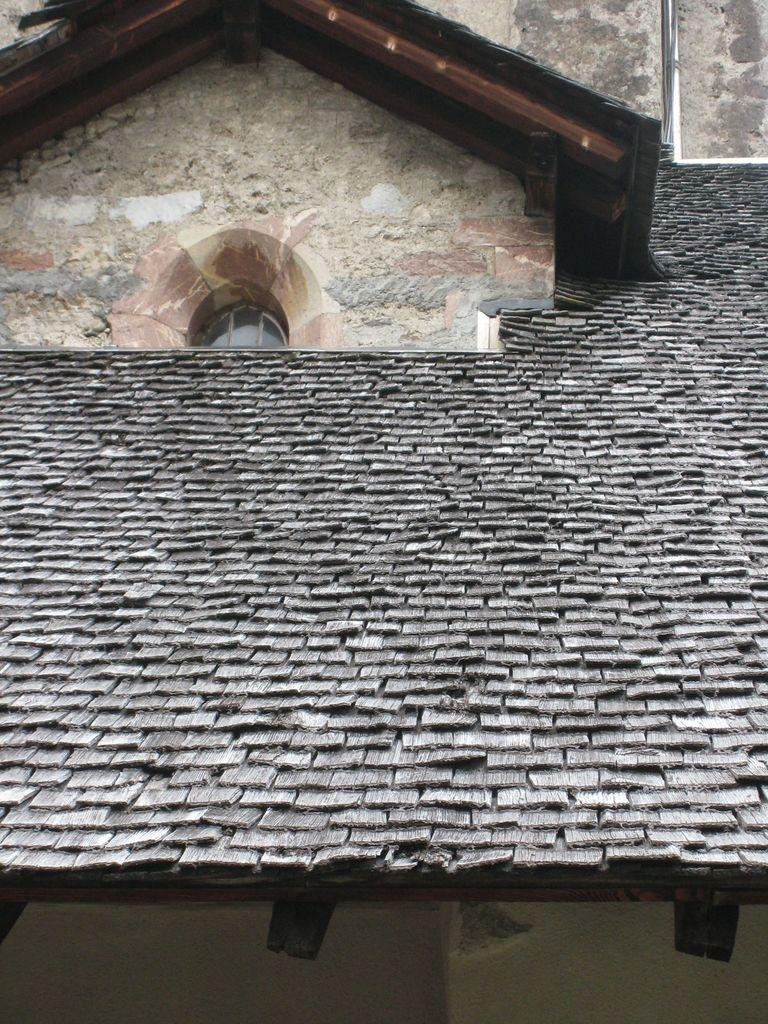What part of a house is shown in the image? The image shows the roof of a house. Can you describe any specific features on the roof? There is a window on the left side of the image. What else can be seen at the bottom of the image? The wall is visible at the bottom of the image. What type of sweater is hanging on the wall in the image? There is no sweater present in the image; it only shows the roof of a house with a window and a wall. 